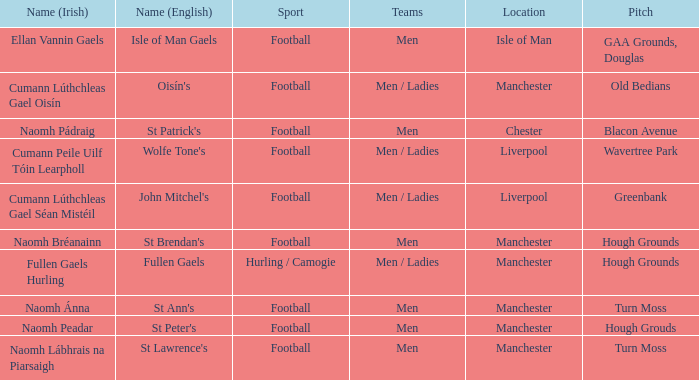What is the English Name of the Location in Chester? St Patrick's. 